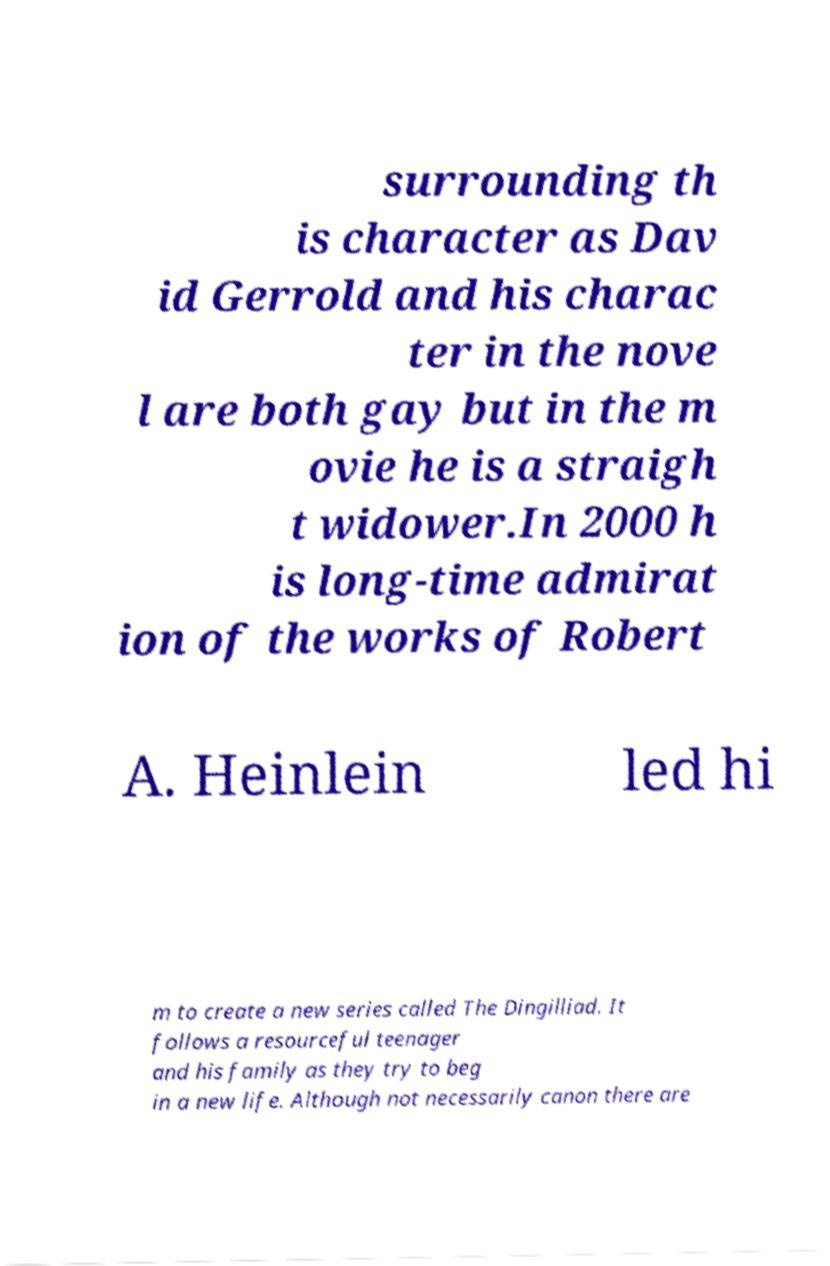Please identify and transcribe the text found in this image. surrounding th is character as Dav id Gerrold and his charac ter in the nove l are both gay but in the m ovie he is a straigh t widower.In 2000 h is long-time admirat ion of the works of Robert A. Heinlein led hi m to create a new series called The Dingilliad. It follows a resourceful teenager and his family as they try to beg in a new life. Although not necessarily canon there are 